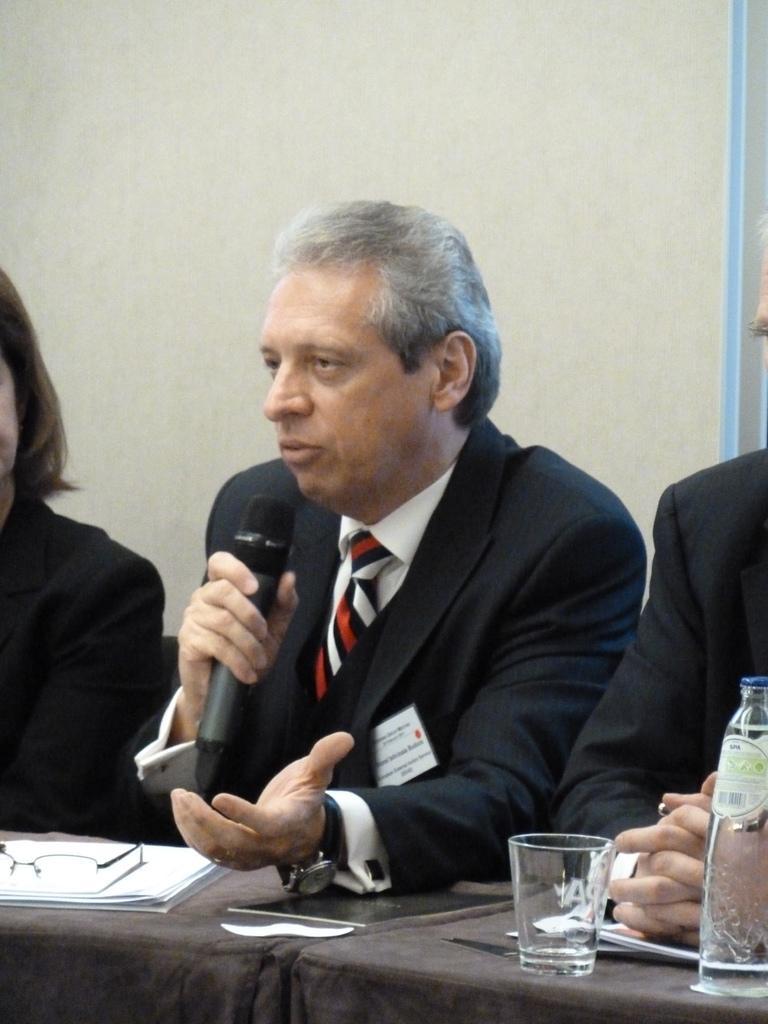Can you describe this image briefly? In this picture, In the middle there is a man who is sitting and holding a microphone and he is speaking in the microphone and in the background there is a white color wall. 